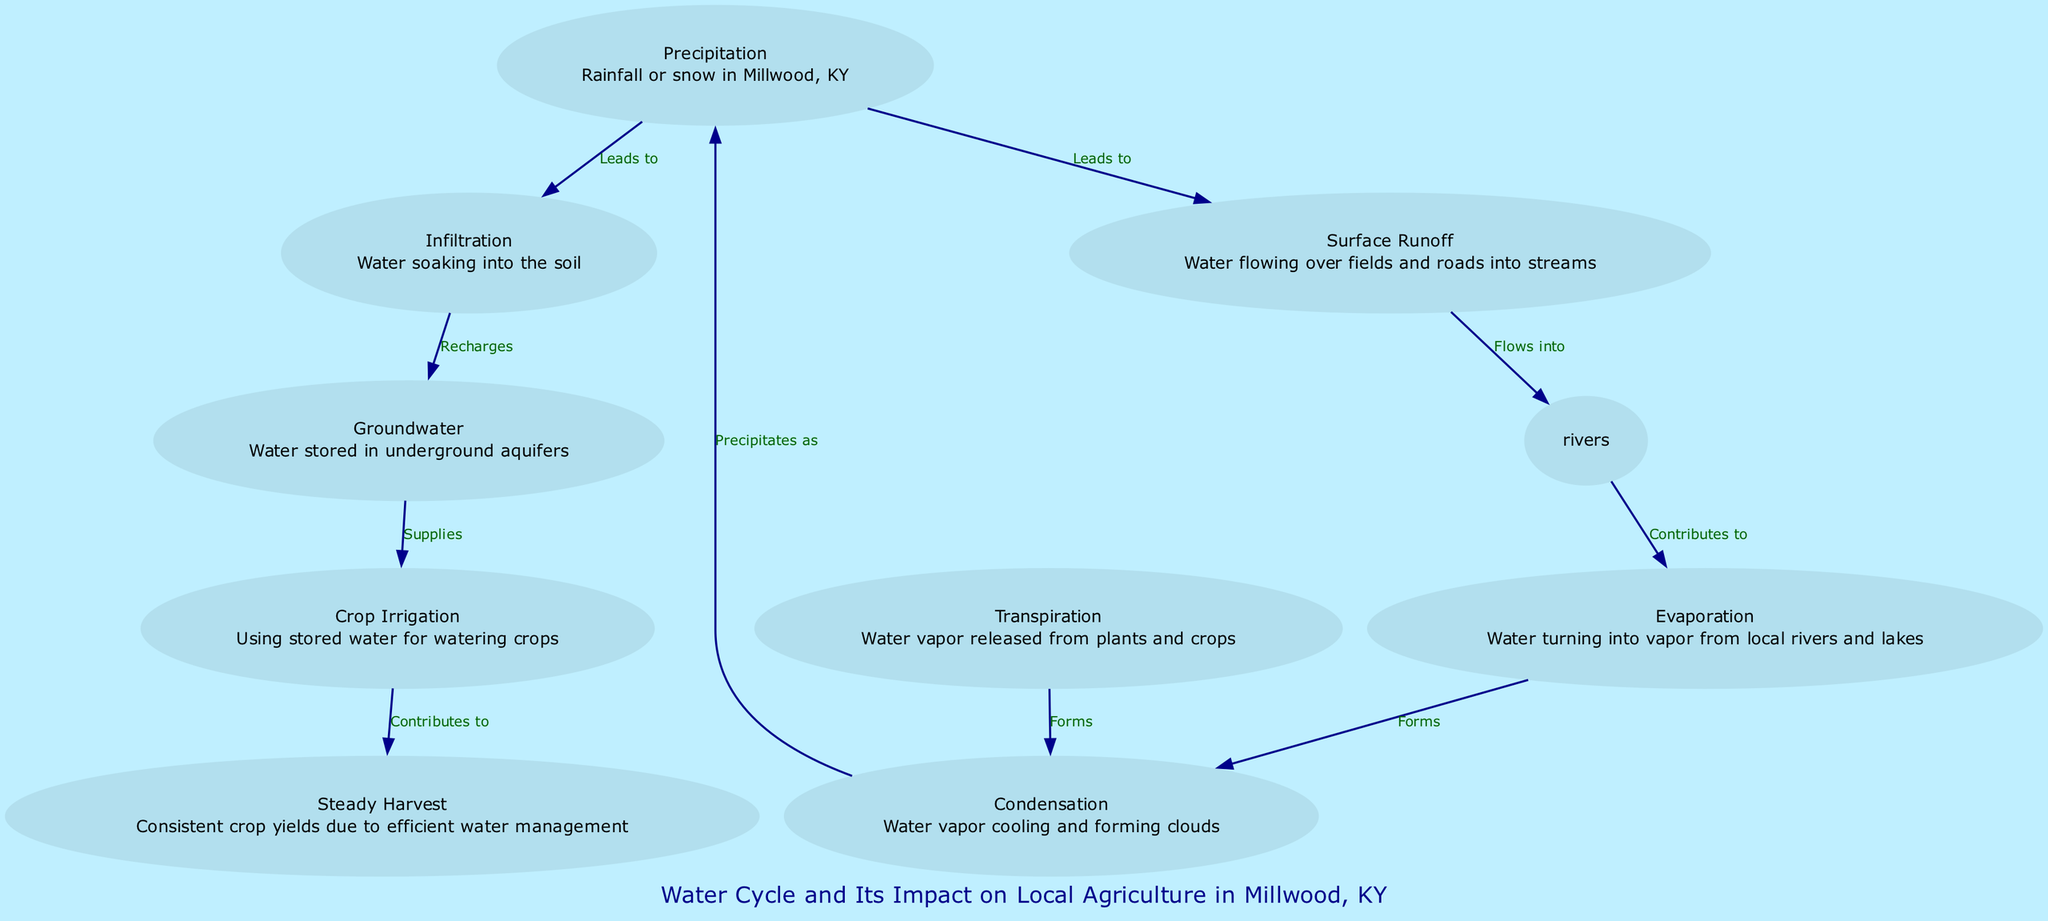What are the two main outcomes of precipitation in the diagram? The diagram shows that precipitation leads to surface runoff and infiltration, as indicated by the edges connecting the precipitation node to those two outcomes.
Answer: surface runoff, infiltration How many nodes are present in the diagram? Counting all the distinct nodes depicted in the diagram, there are a total of ten nodes including all the components of the water cycle and agriculture.
Answer: ten What does groundwater supply to in the context of the diagram? The edge from groundwater to crop irrigation in the diagram indicates that groundwater specifically supplies water for crop irrigation, reflecting its role in agricultural practices.
Answer: crop irrigation Which process is directly influenced by both evaporation and transpiration? Looking at the diagram, both evaporation and transpiration contribute water vapor to the condensation process, leading to cloud formation. Thus, condensation is influenced by both processes.
Answer: condensation How does surface runoff ultimately affect rivers according to the diagram? The diagram illustrates that surface runoff flows into rivers, establishing a direct connection that emphasizes the impact of surface runoff on river water levels.
Answer: flows into What is the final product of condensation as indicated in the diagram? The diagram specifies that condensation leads to precipitation, thereby showing that the cooling of water vapor results in rain or snow falling.
Answer: precipitation What process contributes to steady harvest according to the diagram? The diagram indicates that crop irrigation contributes to steady harvest, highlighting the importance of water management in achieving consistent crop yields.
Answer: crop irrigation Identify a process that results from evaporation in the water cycle. The diagram directly shows that evaporation contributes to condensation, indicating a linkage between these two processes in the water cycle.
Answer: condensation What role does infiltration play in the water cycle? The diagram states that infiltration recharges groundwater, illustrating the significance of this process in replenishing underground water sources.
Answer: recharges 